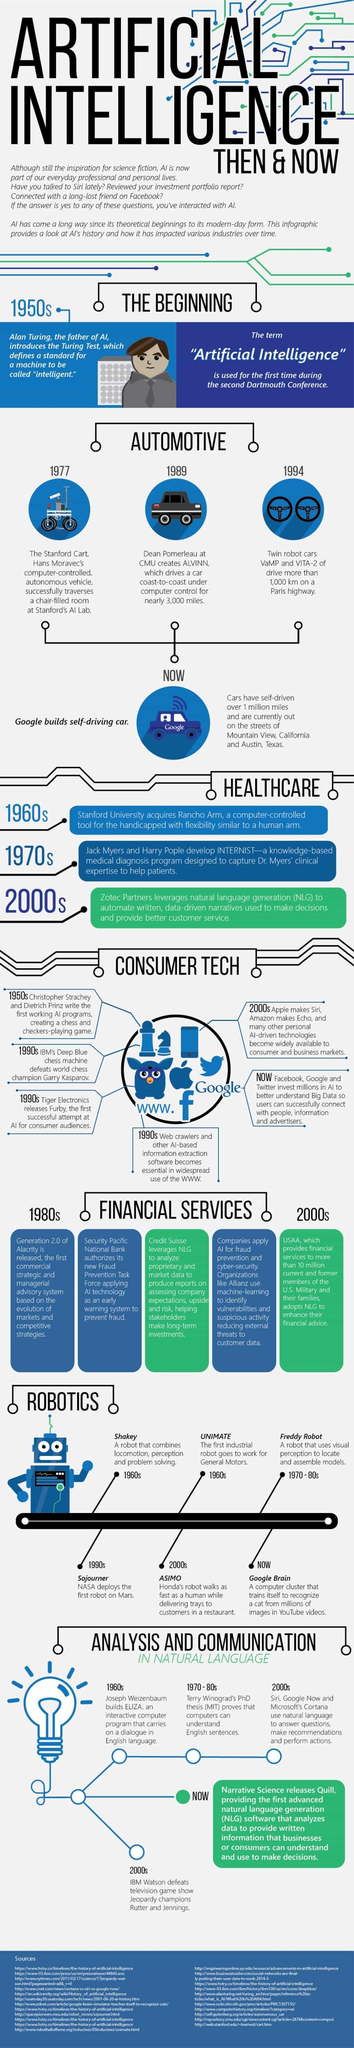Which was the English conversation computer program created in the '60s?
Answer the question with a short phrase. ELIZA What was the name of the autonomous vehicle created in 1977? The Stanford Cart Who lost to IBM's Deep Blue chess machine in 1990s? Garry Kasparov Which was the first robot on Mars? Sojourner In which year were the twin cars VaMP and VITA-2 tested? 1994 Which robot of the '70s could locate and assemble models using visual perception? Freddy Robot In which year was the computer controlled car named ALVINN created? 1989 Which robot was created to work for General Motors? UNIMATE Which AI program was created by Christopher Strachey and Dietrich Prinz? a chess and checkers-playing game Which was the perceptive and problem solving robot created in the 1960s? Shakey 